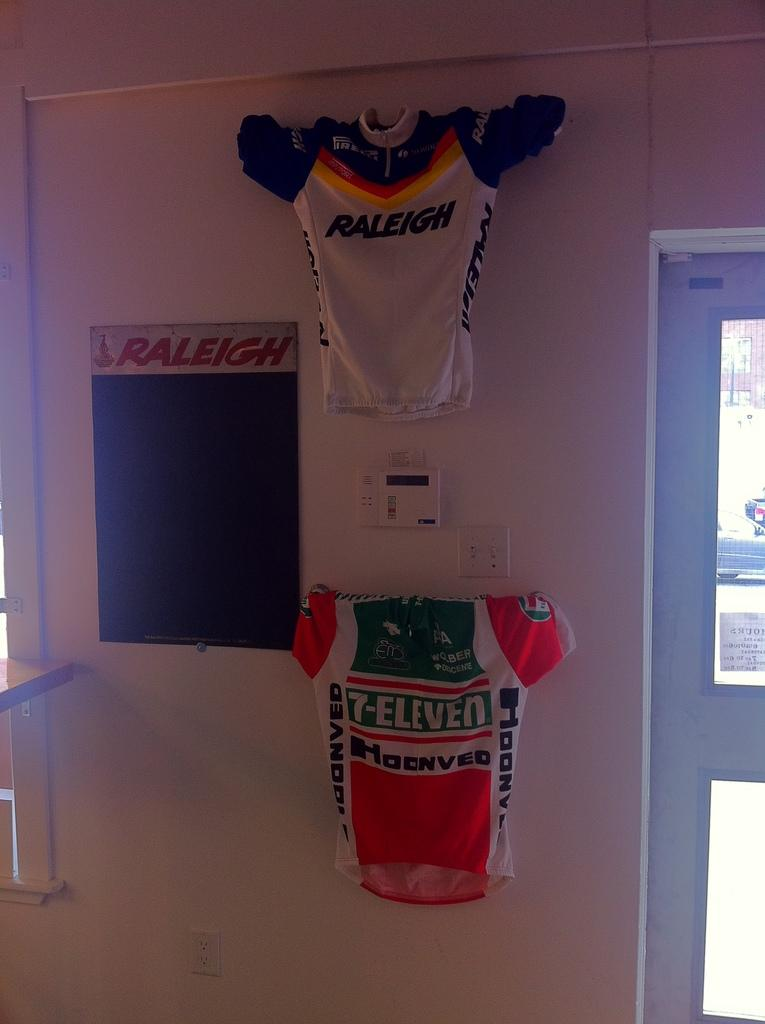<image>
Share a concise interpretation of the image provided. a couple of jerseys one that says Raleigh on it 